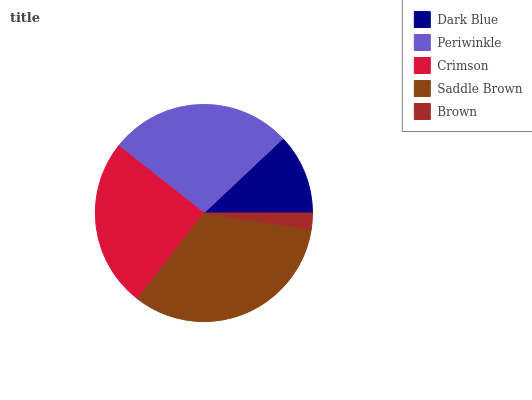Is Brown the minimum?
Answer yes or no. Yes. Is Saddle Brown the maximum?
Answer yes or no. Yes. Is Periwinkle the minimum?
Answer yes or no. No. Is Periwinkle the maximum?
Answer yes or no. No. Is Periwinkle greater than Dark Blue?
Answer yes or no. Yes. Is Dark Blue less than Periwinkle?
Answer yes or no. Yes. Is Dark Blue greater than Periwinkle?
Answer yes or no. No. Is Periwinkle less than Dark Blue?
Answer yes or no. No. Is Crimson the high median?
Answer yes or no. Yes. Is Crimson the low median?
Answer yes or no. Yes. Is Saddle Brown the high median?
Answer yes or no. No. Is Periwinkle the low median?
Answer yes or no. No. 